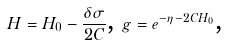Convert formula to latex. <formula><loc_0><loc_0><loc_500><loc_500>H = H _ { 0 } - \frac { \delta \sigma } { 2 C } \text {, } g = e ^ { - \eta - 2 C H _ { 0 } } \text {,}</formula> 